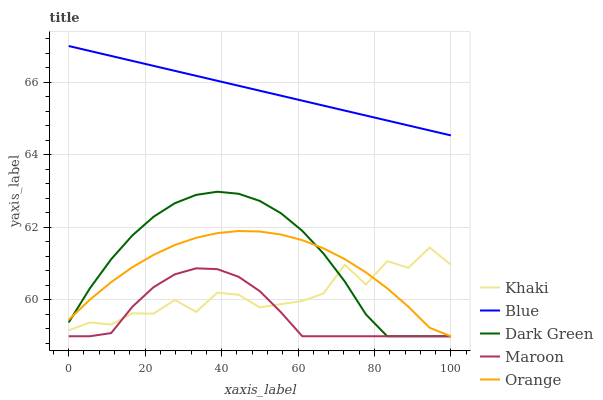Does Maroon have the minimum area under the curve?
Answer yes or no. Yes. Does Blue have the maximum area under the curve?
Answer yes or no. Yes. Does Orange have the minimum area under the curve?
Answer yes or no. No. Does Orange have the maximum area under the curve?
Answer yes or no. No. Is Blue the smoothest?
Answer yes or no. Yes. Is Khaki the roughest?
Answer yes or no. Yes. Is Orange the smoothest?
Answer yes or no. No. Is Orange the roughest?
Answer yes or no. No. Does Orange have the lowest value?
Answer yes or no. Yes. Does Khaki have the lowest value?
Answer yes or no. No. Does Blue have the highest value?
Answer yes or no. Yes. Does Orange have the highest value?
Answer yes or no. No. Is Dark Green less than Blue?
Answer yes or no. Yes. Is Blue greater than Maroon?
Answer yes or no. Yes. Does Dark Green intersect Orange?
Answer yes or no. Yes. Is Dark Green less than Orange?
Answer yes or no. No. Is Dark Green greater than Orange?
Answer yes or no. No. Does Dark Green intersect Blue?
Answer yes or no. No. 